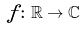<formula> <loc_0><loc_0><loc_500><loc_500>f \colon \mathbb { R } \to \mathbb { C }</formula> 